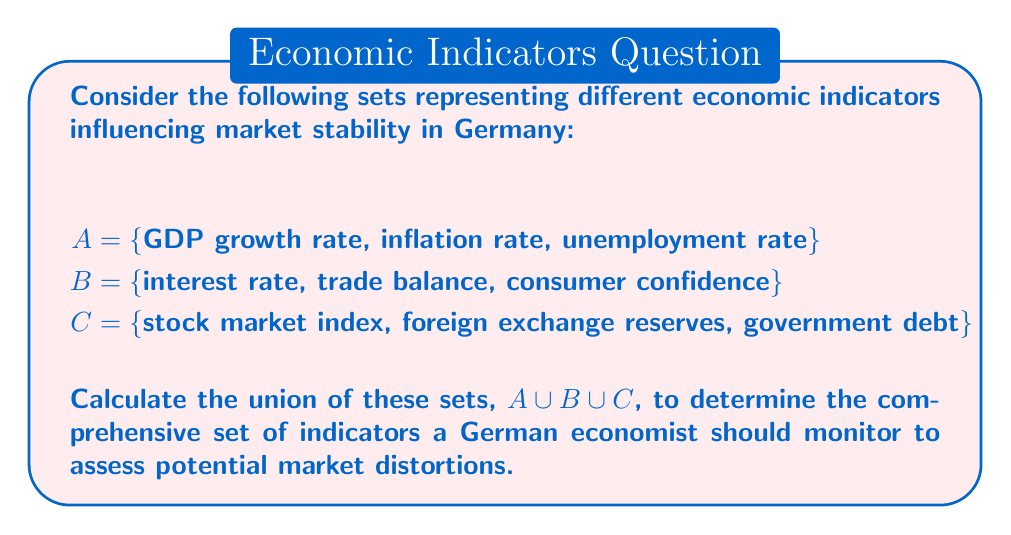Can you solve this math problem? To solve this problem, we need to understand the concept of union in set theory and apply it to the given sets.

1. The union of sets is an operation that combines all unique elements from the given sets into a single set.

2. The union of sets A, B, and C is denoted as $A \cup B \cup C$.

3. To calculate the union, we list all elements from set A, then add any elements from set B that are not already in the result, and finally add any elements from set C that are not yet included.

4. Let's proceed step by step:

   Step 1: Start with set A
   $\{GDP growth rate, inflation rate, unemployment rate\}$

   Step 2: Add unique elements from set B
   $\{GDP growth rate, inflation rate, unemployment rate, interest rate, trade balance, consumer confidence\}$

   Step 3: Add unique elements from set C
   $\{GDP growth rate, inflation rate, unemployment rate, interest rate, trade balance, consumer confidence, stock market index, foreign exchange reserves, government debt\}$

5. The resulting set contains all unique elements from sets A, B, and C, representing the comprehensive set of economic indicators influencing market stability.

This union provides a holistic view of the factors a German economist should consider when assessing potential market distortions, encompassing various aspects of the economy such as growth, monetary policy, trade, consumer behavior, and financial markets.
Answer: $A \cup B \cup C = \{GDP growth rate, inflation rate, unemployment rate, interest rate, trade balance, consumer confidence, stock market index, foreign exchange reserves, government debt\}$ 